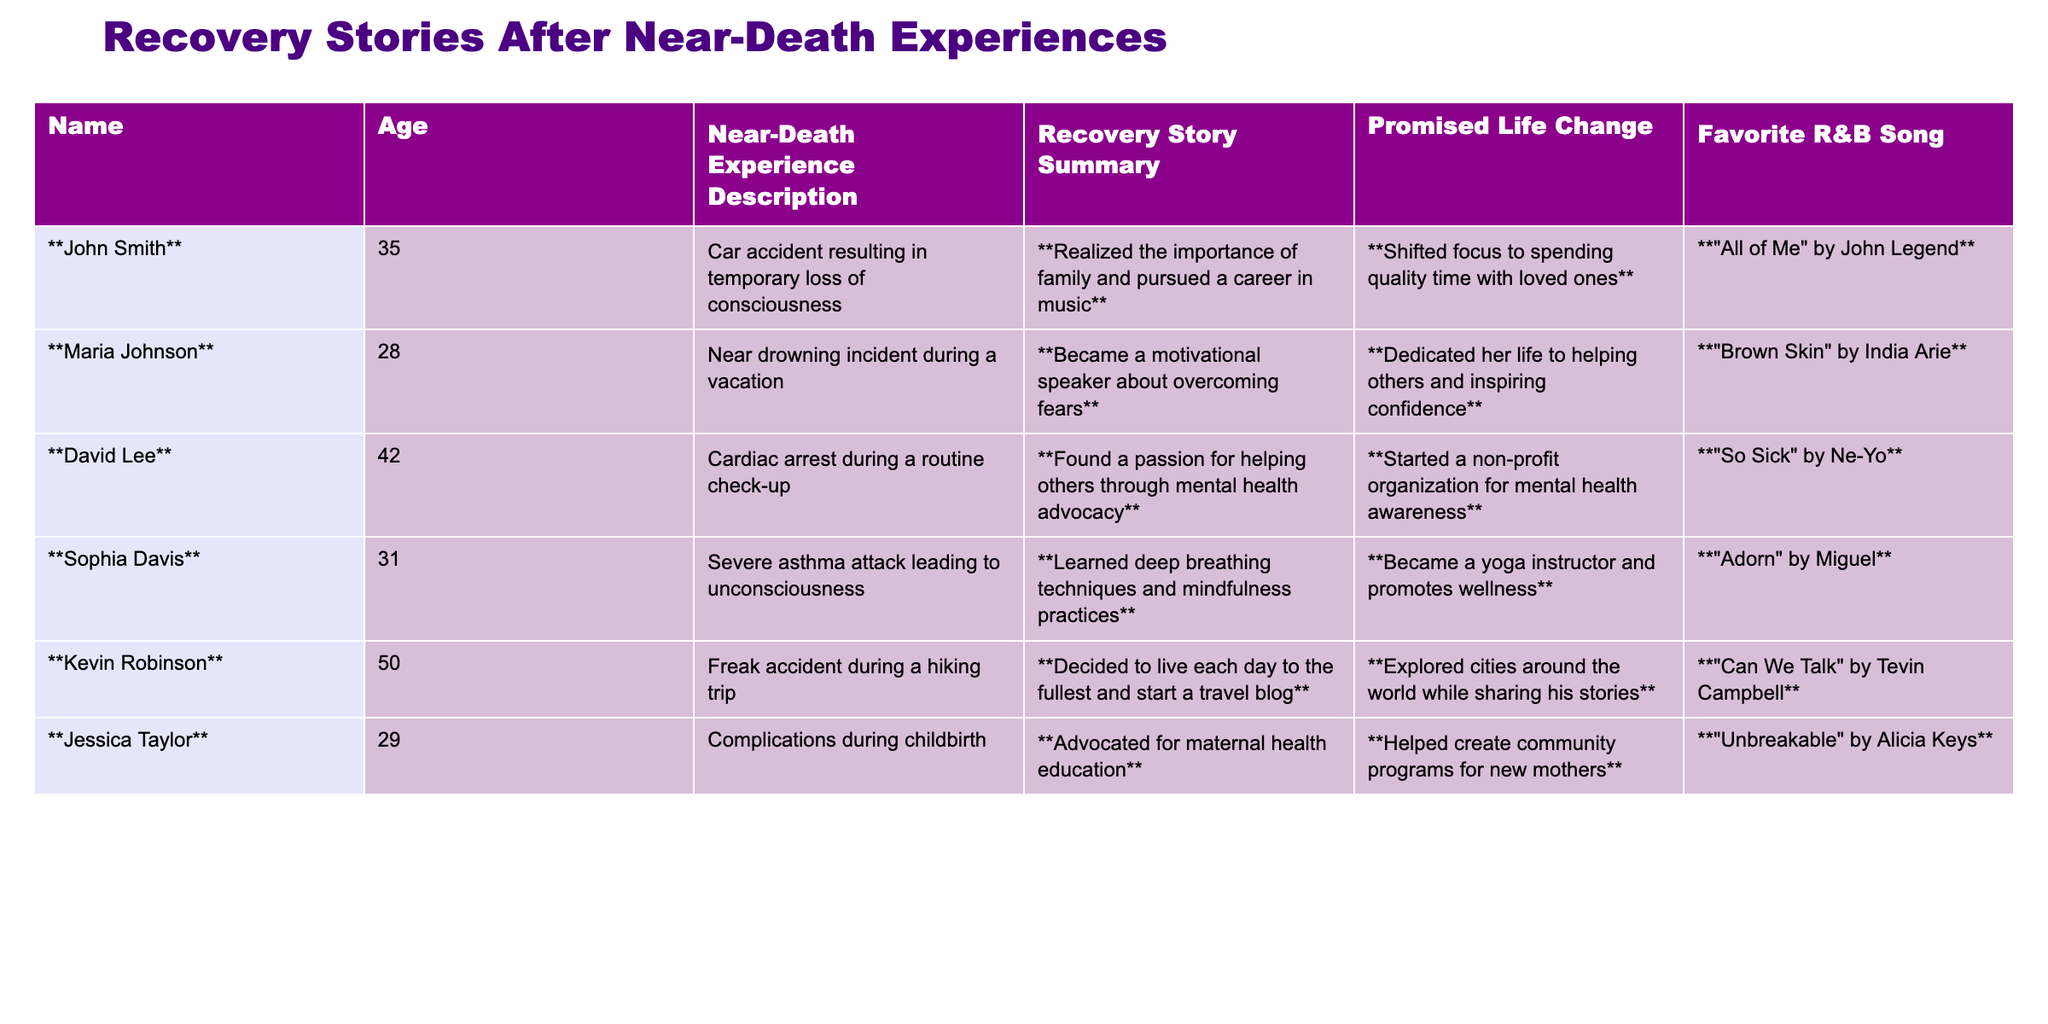What was the near-death experience of John Smith? The table states that John Smith's near-death experience was a car accident resulting in temporary loss of consciousness.
Answer: Car accident resulting in temporary loss of consciousness Which recovery story involved a focus on mental health? The table shows that David Lee found a passion for helping others through mental health advocacy as his recovery story.
Answer: David Lee How many people promised to dedicate their lives to helping others? By counting the entries, both Maria Johnson and David Lee promised to dedicate their lives to helping others, making a total of 2 people.
Answer: 2 What is Jessica Taylor's favorite R&B song? According to the table, Jessica Taylor's favorite R&B song is "Unbreakable" by Alicia Keys.
Answer: "Unbreakable" by Alicia Keys Which individual experienced a severe asthma attack? The table lists Sophia Davis as the individual who experienced a severe asthma attack leading to unconsciousness.
Answer: Sophia Davis Did Kevin Robinson start a travel blog after his near-death experience? Yes, the table indicates that Kevin Robinson decided to start a travel blog after his freak accident during a hiking trip.
Answer: Yes Who among them became a motivational speaker? From the table, it is clear that Maria Johnson became a motivational speaker about overcoming fears.
Answer: Maria Johnson What general theme can be observed from their promised life changes? The individuals in the table generally promised life changes oriented towards helping others, pursuing passions, or improving personal well-being (spending quality time, advocating, etc.).
Answer: Helping others and personal well-being Are there any individuals older than 40 in the table? Yes, David Lee and Kevin Robinson are older than 40, as their ages are 42 and 50 respectively.
Answer: Yes Which two recovery stories involve advocacy for health education? The recovery stories of David Lee (mental health advocacy) and Jessica Taylor (maternal health education) both involve advocacy for health education.
Answer: David Lee and Jessica Taylor 